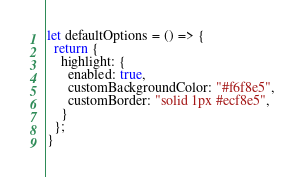<code> <loc_0><loc_0><loc_500><loc_500><_JavaScript_>let defaultOptions = () => {
  return {
    highlight: {
      enabled: true,
      customBackgroundColor: "#f6f8e5",
      customBorder: "solid 1px #ecf8e5",
    }
  };
}
</code> 